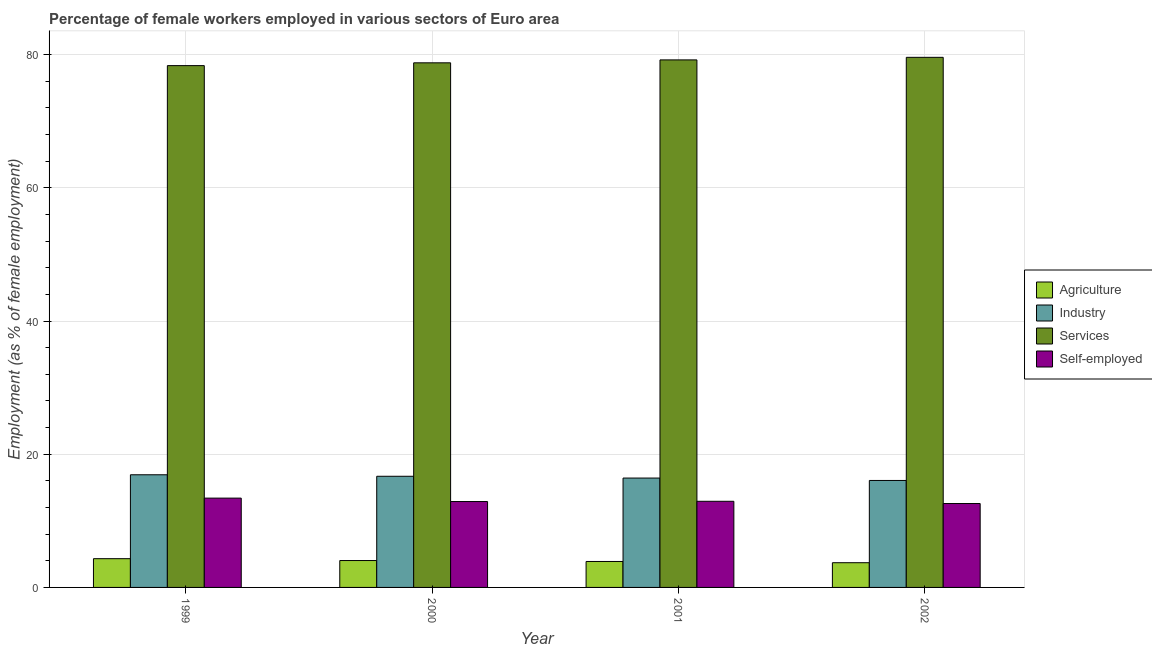How many bars are there on the 3rd tick from the right?
Offer a very short reply. 4. What is the label of the 2nd group of bars from the left?
Ensure brevity in your answer.  2000. What is the percentage of female workers in services in 1999?
Provide a succinct answer. 78.35. Across all years, what is the maximum percentage of female workers in agriculture?
Your answer should be very brief. 4.32. Across all years, what is the minimum percentage of female workers in services?
Give a very brief answer. 78.35. In which year was the percentage of female workers in industry maximum?
Make the answer very short. 1999. What is the total percentage of self employed female workers in the graph?
Your answer should be very brief. 51.84. What is the difference between the percentage of female workers in industry in 2001 and that in 2002?
Give a very brief answer. 0.36. What is the difference between the percentage of female workers in agriculture in 2001 and the percentage of self employed female workers in 2000?
Your answer should be very brief. -0.14. What is the average percentage of self employed female workers per year?
Ensure brevity in your answer.  12.96. In the year 2002, what is the difference between the percentage of female workers in services and percentage of self employed female workers?
Ensure brevity in your answer.  0. In how many years, is the percentage of self employed female workers greater than 52 %?
Provide a succinct answer. 0. What is the ratio of the percentage of female workers in industry in 1999 to that in 2001?
Your response must be concise. 1.03. Is the difference between the percentage of self employed female workers in 2001 and 2002 greater than the difference between the percentage of female workers in services in 2001 and 2002?
Your response must be concise. No. What is the difference between the highest and the second highest percentage of self employed female workers?
Provide a short and direct response. 0.47. What is the difference between the highest and the lowest percentage of female workers in services?
Your answer should be very brief. 1.24. What does the 4th bar from the left in 2002 represents?
Ensure brevity in your answer.  Self-employed. What does the 3rd bar from the right in 2000 represents?
Offer a terse response. Industry. Are all the bars in the graph horizontal?
Keep it short and to the point. No. How many years are there in the graph?
Provide a succinct answer. 4. Does the graph contain any zero values?
Give a very brief answer. No. Does the graph contain grids?
Provide a succinct answer. Yes. Where does the legend appear in the graph?
Provide a short and direct response. Center right. How many legend labels are there?
Provide a succinct answer. 4. How are the legend labels stacked?
Provide a short and direct response. Vertical. What is the title of the graph?
Keep it short and to the point. Percentage of female workers employed in various sectors of Euro area. Does "Regional development banks" appear as one of the legend labels in the graph?
Your answer should be very brief. No. What is the label or title of the Y-axis?
Your answer should be very brief. Employment (as % of female employment). What is the Employment (as % of female employment) in Agriculture in 1999?
Give a very brief answer. 4.32. What is the Employment (as % of female employment) in Industry in 1999?
Provide a succinct answer. 16.92. What is the Employment (as % of female employment) in Services in 1999?
Ensure brevity in your answer.  78.35. What is the Employment (as % of female employment) of Self-employed in 1999?
Offer a very short reply. 13.41. What is the Employment (as % of female employment) of Agriculture in 2000?
Your response must be concise. 4.04. What is the Employment (as % of female employment) in Industry in 2000?
Your response must be concise. 16.69. What is the Employment (as % of female employment) in Services in 2000?
Give a very brief answer. 78.77. What is the Employment (as % of female employment) of Self-employed in 2000?
Ensure brevity in your answer.  12.9. What is the Employment (as % of female employment) of Agriculture in 2001?
Your answer should be very brief. 3.9. What is the Employment (as % of female employment) in Industry in 2001?
Make the answer very short. 16.42. What is the Employment (as % of female employment) of Services in 2001?
Your answer should be very brief. 79.21. What is the Employment (as % of female employment) of Self-employed in 2001?
Make the answer very short. 12.93. What is the Employment (as % of female employment) in Agriculture in 2002?
Your response must be concise. 3.71. What is the Employment (as % of female employment) in Industry in 2002?
Ensure brevity in your answer.  16.06. What is the Employment (as % of female employment) in Services in 2002?
Your response must be concise. 79.6. What is the Employment (as % of female employment) in Self-employed in 2002?
Keep it short and to the point. 12.6. Across all years, what is the maximum Employment (as % of female employment) of Agriculture?
Offer a terse response. 4.32. Across all years, what is the maximum Employment (as % of female employment) of Industry?
Offer a terse response. 16.92. Across all years, what is the maximum Employment (as % of female employment) of Services?
Your answer should be compact. 79.6. Across all years, what is the maximum Employment (as % of female employment) in Self-employed?
Ensure brevity in your answer.  13.41. Across all years, what is the minimum Employment (as % of female employment) in Agriculture?
Your response must be concise. 3.71. Across all years, what is the minimum Employment (as % of female employment) in Industry?
Your response must be concise. 16.06. Across all years, what is the minimum Employment (as % of female employment) in Services?
Make the answer very short. 78.35. Across all years, what is the minimum Employment (as % of female employment) of Self-employed?
Ensure brevity in your answer.  12.6. What is the total Employment (as % of female employment) in Agriculture in the graph?
Offer a very short reply. 15.96. What is the total Employment (as % of female employment) in Industry in the graph?
Your answer should be compact. 66.09. What is the total Employment (as % of female employment) in Services in the graph?
Keep it short and to the point. 315.93. What is the total Employment (as % of female employment) of Self-employed in the graph?
Your answer should be very brief. 51.84. What is the difference between the Employment (as % of female employment) in Agriculture in 1999 and that in 2000?
Give a very brief answer. 0.28. What is the difference between the Employment (as % of female employment) in Industry in 1999 and that in 2000?
Your answer should be compact. 0.23. What is the difference between the Employment (as % of female employment) in Services in 1999 and that in 2000?
Offer a very short reply. -0.42. What is the difference between the Employment (as % of female employment) of Self-employed in 1999 and that in 2000?
Your answer should be very brief. 0.51. What is the difference between the Employment (as % of female employment) of Agriculture in 1999 and that in 2001?
Keep it short and to the point. 0.42. What is the difference between the Employment (as % of female employment) in Industry in 1999 and that in 2001?
Provide a short and direct response. 0.49. What is the difference between the Employment (as % of female employment) of Services in 1999 and that in 2001?
Your response must be concise. -0.86. What is the difference between the Employment (as % of female employment) in Self-employed in 1999 and that in 2001?
Ensure brevity in your answer.  0.47. What is the difference between the Employment (as % of female employment) in Agriculture in 1999 and that in 2002?
Make the answer very short. 0.61. What is the difference between the Employment (as % of female employment) of Industry in 1999 and that in 2002?
Offer a terse response. 0.85. What is the difference between the Employment (as % of female employment) in Services in 1999 and that in 2002?
Your answer should be compact. -1.24. What is the difference between the Employment (as % of female employment) in Self-employed in 1999 and that in 2002?
Provide a short and direct response. 0.81. What is the difference between the Employment (as % of female employment) in Agriculture in 2000 and that in 2001?
Your response must be concise. 0.14. What is the difference between the Employment (as % of female employment) of Industry in 2000 and that in 2001?
Your answer should be compact. 0.27. What is the difference between the Employment (as % of female employment) in Services in 2000 and that in 2001?
Provide a short and direct response. -0.44. What is the difference between the Employment (as % of female employment) of Self-employed in 2000 and that in 2001?
Give a very brief answer. -0.04. What is the difference between the Employment (as % of female employment) in Agriculture in 2000 and that in 2002?
Your answer should be compact. 0.33. What is the difference between the Employment (as % of female employment) of Industry in 2000 and that in 2002?
Offer a very short reply. 0.63. What is the difference between the Employment (as % of female employment) of Services in 2000 and that in 2002?
Provide a succinct answer. -0.82. What is the difference between the Employment (as % of female employment) of Self-employed in 2000 and that in 2002?
Your response must be concise. 0.3. What is the difference between the Employment (as % of female employment) of Agriculture in 2001 and that in 2002?
Offer a terse response. 0.19. What is the difference between the Employment (as % of female employment) of Industry in 2001 and that in 2002?
Offer a very short reply. 0.36. What is the difference between the Employment (as % of female employment) in Services in 2001 and that in 2002?
Provide a succinct answer. -0.39. What is the difference between the Employment (as % of female employment) of Self-employed in 2001 and that in 2002?
Your answer should be compact. 0.34. What is the difference between the Employment (as % of female employment) in Agriculture in 1999 and the Employment (as % of female employment) in Industry in 2000?
Offer a very short reply. -12.37. What is the difference between the Employment (as % of female employment) of Agriculture in 1999 and the Employment (as % of female employment) of Services in 2000?
Ensure brevity in your answer.  -74.45. What is the difference between the Employment (as % of female employment) of Agriculture in 1999 and the Employment (as % of female employment) of Self-employed in 2000?
Your response must be concise. -8.58. What is the difference between the Employment (as % of female employment) of Industry in 1999 and the Employment (as % of female employment) of Services in 2000?
Offer a terse response. -61.86. What is the difference between the Employment (as % of female employment) of Industry in 1999 and the Employment (as % of female employment) of Self-employed in 2000?
Keep it short and to the point. 4.02. What is the difference between the Employment (as % of female employment) of Services in 1999 and the Employment (as % of female employment) of Self-employed in 2000?
Ensure brevity in your answer.  65.46. What is the difference between the Employment (as % of female employment) of Agriculture in 1999 and the Employment (as % of female employment) of Industry in 2001?
Provide a succinct answer. -12.11. What is the difference between the Employment (as % of female employment) in Agriculture in 1999 and the Employment (as % of female employment) in Services in 2001?
Your answer should be compact. -74.89. What is the difference between the Employment (as % of female employment) of Agriculture in 1999 and the Employment (as % of female employment) of Self-employed in 2001?
Your answer should be compact. -8.62. What is the difference between the Employment (as % of female employment) in Industry in 1999 and the Employment (as % of female employment) in Services in 2001?
Your response must be concise. -62.29. What is the difference between the Employment (as % of female employment) in Industry in 1999 and the Employment (as % of female employment) in Self-employed in 2001?
Make the answer very short. 3.98. What is the difference between the Employment (as % of female employment) in Services in 1999 and the Employment (as % of female employment) in Self-employed in 2001?
Make the answer very short. 65.42. What is the difference between the Employment (as % of female employment) of Agriculture in 1999 and the Employment (as % of female employment) of Industry in 2002?
Provide a short and direct response. -11.74. What is the difference between the Employment (as % of female employment) of Agriculture in 1999 and the Employment (as % of female employment) of Services in 2002?
Provide a succinct answer. -75.28. What is the difference between the Employment (as % of female employment) of Agriculture in 1999 and the Employment (as % of female employment) of Self-employed in 2002?
Provide a short and direct response. -8.28. What is the difference between the Employment (as % of female employment) in Industry in 1999 and the Employment (as % of female employment) in Services in 2002?
Give a very brief answer. -62.68. What is the difference between the Employment (as % of female employment) in Industry in 1999 and the Employment (as % of female employment) in Self-employed in 2002?
Keep it short and to the point. 4.32. What is the difference between the Employment (as % of female employment) of Services in 1999 and the Employment (as % of female employment) of Self-employed in 2002?
Provide a short and direct response. 65.75. What is the difference between the Employment (as % of female employment) of Agriculture in 2000 and the Employment (as % of female employment) of Industry in 2001?
Your answer should be compact. -12.38. What is the difference between the Employment (as % of female employment) of Agriculture in 2000 and the Employment (as % of female employment) of Services in 2001?
Make the answer very short. -75.17. What is the difference between the Employment (as % of female employment) in Agriculture in 2000 and the Employment (as % of female employment) in Self-employed in 2001?
Offer a very short reply. -8.9. What is the difference between the Employment (as % of female employment) of Industry in 2000 and the Employment (as % of female employment) of Services in 2001?
Give a very brief answer. -62.52. What is the difference between the Employment (as % of female employment) in Industry in 2000 and the Employment (as % of female employment) in Self-employed in 2001?
Ensure brevity in your answer.  3.76. What is the difference between the Employment (as % of female employment) in Services in 2000 and the Employment (as % of female employment) in Self-employed in 2001?
Offer a terse response. 65.84. What is the difference between the Employment (as % of female employment) in Agriculture in 2000 and the Employment (as % of female employment) in Industry in 2002?
Offer a very short reply. -12.02. What is the difference between the Employment (as % of female employment) of Agriculture in 2000 and the Employment (as % of female employment) of Services in 2002?
Keep it short and to the point. -75.56. What is the difference between the Employment (as % of female employment) in Agriculture in 2000 and the Employment (as % of female employment) in Self-employed in 2002?
Provide a succinct answer. -8.56. What is the difference between the Employment (as % of female employment) in Industry in 2000 and the Employment (as % of female employment) in Services in 2002?
Provide a short and direct response. -62.91. What is the difference between the Employment (as % of female employment) of Industry in 2000 and the Employment (as % of female employment) of Self-employed in 2002?
Keep it short and to the point. 4.09. What is the difference between the Employment (as % of female employment) of Services in 2000 and the Employment (as % of female employment) of Self-employed in 2002?
Offer a very short reply. 66.17. What is the difference between the Employment (as % of female employment) of Agriculture in 2001 and the Employment (as % of female employment) of Industry in 2002?
Make the answer very short. -12.17. What is the difference between the Employment (as % of female employment) in Agriculture in 2001 and the Employment (as % of female employment) in Services in 2002?
Provide a succinct answer. -75.7. What is the difference between the Employment (as % of female employment) of Agriculture in 2001 and the Employment (as % of female employment) of Self-employed in 2002?
Offer a very short reply. -8.7. What is the difference between the Employment (as % of female employment) in Industry in 2001 and the Employment (as % of female employment) in Services in 2002?
Provide a short and direct response. -63.17. What is the difference between the Employment (as % of female employment) in Industry in 2001 and the Employment (as % of female employment) in Self-employed in 2002?
Keep it short and to the point. 3.82. What is the difference between the Employment (as % of female employment) in Services in 2001 and the Employment (as % of female employment) in Self-employed in 2002?
Provide a succinct answer. 66.61. What is the average Employment (as % of female employment) in Agriculture per year?
Offer a very short reply. 3.99. What is the average Employment (as % of female employment) of Industry per year?
Provide a short and direct response. 16.52. What is the average Employment (as % of female employment) of Services per year?
Your answer should be very brief. 78.98. What is the average Employment (as % of female employment) of Self-employed per year?
Ensure brevity in your answer.  12.96. In the year 1999, what is the difference between the Employment (as % of female employment) in Agriculture and Employment (as % of female employment) in Industry?
Provide a succinct answer. -12.6. In the year 1999, what is the difference between the Employment (as % of female employment) of Agriculture and Employment (as % of female employment) of Services?
Provide a short and direct response. -74.04. In the year 1999, what is the difference between the Employment (as % of female employment) of Agriculture and Employment (as % of female employment) of Self-employed?
Offer a terse response. -9.09. In the year 1999, what is the difference between the Employment (as % of female employment) in Industry and Employment (as % of female employment) in Services?
Your answer should be very brief. -61.44. In the year 1999, what is the difference between the Employment (as % of female employment) in Industry and Employment (as % of female employment) in Self-employed?
Provide a succinct answer. 3.51. In the year 1999, what is the difference between the Employment (as % of female employment) of Services and Employment (as % of female employment) of Self-employed?
Your answer should be compact. 64.94. In the year 2000, what is the difference between the Employment (as % of female employment) of Agriculture and Employment (as % of female employment) of Industry?
Offer a very short reply. -12.65. In the year 2000, what is the difference between the Employment (as % of female employment) of Agriculture and Employment (as % of female employment) of Services?
Offer a terse response. -74.73. In the year 2000, what is the difference between the Employment (as % of female employment) in Agriculture and Employment (as % of female employment) in Self-employed?
Provide a short and direct response. -8.86. In the year 2000, what is the difference between the Employment (as % of female employment) of Industry and Employment (as % of female employment) of Services?
Ensure brevity in your answer.  -62.08. In the year 2000, what is the difference between the Employment (as % of female employment) in Industry and Employment (as % of female employment) in Self-employed?
Offer a very short reply. 3.79. In the year 2000, what is the difference between the Employment (as % of female employment) of Services and Employment (as % of female employment) of Self-employed?
Keep it short and to the point. 65.88. In the year 2001, what is the difference between the Employment (as % of female employment) of Agriculture and Employment (as % of female employment) of Industry?
Keep it short and to the point. -12.53. In the year 2001, what is the difference between the Employment (as % of female employment) of Agriculture and Employment (as % of female employment) of Services?
Make the answer very short. -75.31. In the year 2001, what is the difference between the Employment (as % of female employment) of Agriculture and Employment (as % of female employment) of Self-employed?
Offer a terse response. -9.04. In the year 2001, what is the difference between the Employment (as % of female employment) of Industry and Employment (as % of female employment) of Services?
Your response must be concise. -62.79. In the year 2001, what is the difference between the Employment (as % of female employment) of Industry and Employment (as % of female employment) of Self-employed?
Give a very brief answer. 3.49. In the year 2001, what is the difference between the Employment (as % of female employment) in Services and Employment (as % of female employment) in Self-employed?
Provide a short and direct response. 66.28. In the year 2002, what is the difference between the Employment (as % of female employment) in Agriculture and Employment (as % of female employment) in Industry?
Give a very brief answer. -12.35. In the year 2002, what is the difference between the Employment (as % of female employment) of Agriculture and Employment (as % of female employment) of Services?
Offer a very short reply. -75.89. In the year 2002, what is the difference between the Employment (as % of female employment) in Agriculture and Employment (as % of female employment) in Self-employed?
Provide a short and direct response. -8.89. In the year 2002, what is the difference between the Employment (as % of female employment) of Industry and Employment (as % of female employment) of Services?
Ensure brevity in your answer.  -63.53. In the year 2002, what is the difference between the Employment (as % of female employment) of Industry and Employment (as % of female employment) of Self-employed?
Offer a very short reply. 3.46. In the year 2002, what is the difference between the Employment (as % of female employment) in Services and Employment (as % of female employment) in Self-employed?
Offer a very short reply. 67. What is the ratio of the Employment (as % of female employment) in Agriculture in 1999 to that in 2000?
Provide a succinct answer. 1.07. What is the ratio of the Employment (as % of female employment) of Industry in 1999 to that in 2000?
Your response must be concise. 1.01. What is the ratio of the Employment (as % of female employment) in Services in 1999 to that in 2000?
Give a very brief answer. 0.99. What is the ratio of the Employment (as % of female employment) in Self-employed in 1999 to that in 2000?
Offer a very short reply. 1.04. What is the ratio of the Employment (as % of female employment) of Agriculture in 1999 to that in 2001?
Your answer should be compact. 1.11. What is the ratio of the Employment (as % of female employment) in Industry in 1999 to that in 2001?
Your answer should be compact. 1.03. What is the ratio of the Employment (as % of female employment) of Self-employed in 1999 to that in 2001?
Give a very brief answer. 1.04. What is the ratio of the Employment (as % of female employment) of Agriculture in 1999 to that in 2002?
Offer a very short reply. 1.16. What is the ratio of the Employment (as % of female employment) in Industry in 1999 to that in 2002?
Provide a short and direct response. 1.05. What is the ratio of the Employment (as % of female employment) in Services in 1999 to that in 2002?
Ensure brevity in your answer.  0.98. What is the ratio of the Employment (as % of female employment) of Self-employed in 1999 to that in 2002?
Keep it short and to the point. 1.06. What is the ratio of the Employment (as % of female employment) in Agriculture in 2000 to that in 2001?
Make the answer very short. 1.04. What is the ratio of the Employment (as % of female employment) of Industry in 2000 to that in 2001?
Ensure brevity in your answer.  1.02. What is the ratio of the Employment (as % of female employment) of Agriculture in 2000 to that in 2002?
Provide a succinct answer. 1.09. What is the ratio of the Employment (as % of female employment) of Industry in 2000 to that in 2002?
Your answer should be compact. 1.04. What is the ratio of the Employment (as % of female employment) in Services in 2000 to that in 2002?
Keep it short and to the point. 0.99. What is the ratio of the Employment (as % of female employment) in Self-employed in 2000 to that in 2002?
Your response must be concise. 1.02. What is the ratio of the Employment (as % of female employment) in Agriculture in 2001 to that in 2002?
Your response must be concise. 1.05. What is the ratio of the Employment (as % of female employment) in Industry in 2001 to that in 2002?
Provide a short and direct response. 1.02. What is the ratio of the Employment (as % of female employment) in Self-employed in 2001 to that in 2002?
Keep it short and to the point. 1.03. What is the difference between the highest and the second highest Employment (as % of female employment) in Agriculture?
Your answer should be compact. 0.28. What is the difference between the highest and the second highest Employment (as % of female employment) in Industry?
Ensure brevity in your answer.  0.23. What is the difference between the highest and the second highest Employment (as % of female employment) of Services?
Make the answer very short. 0.39. What is the difference between the highest and the second highest Employment (as % of female employment) of Self-employed?
Provide a short and direct response. 0.47. What is the difference between the highest and the lowest Employment (as % of female employment) in Agriculture?
Offer a terse response. 0.61. What is the difference between the highest and the lowest Employment (as % of female employment) in Industry?
Give a very brief answer. 0.85. What is the difference between the highest and the lowest Employment (as % of female employment) in Services?
Provide a short and direct response. 1.24. What is the difference between the highest and the lowest Employment (as % of female employment) in Self-employed?
Keep it short and to the point. 0.81. 